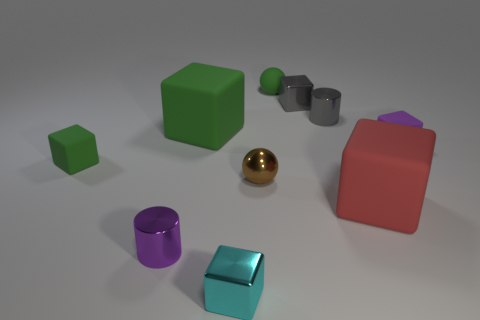Subtract all small cyan metallic cubes. How many cubes are left? 5 Subtract all blue spheres. How many green blocks are left? 2 Subtract 3 blocks. How many blocks are left? 3 Subtract all gray blocks. How many blocks are left? 5 Subtract all blocks. How many objects are left? 4 Subtract 0 yellow cylinders. How many objects are left? 10 Subtract all purple blocks. Subtract all blue spheres. How many blocks are left? 5 Subtract all small cyan cubes. Subtract all tiny brown cylinders. How many objects are left? 9 Add 7 matte balls. How many matte balls are left? 8 Add 2 big yellow shiny things. How many big yellow shiny things exist? 2 